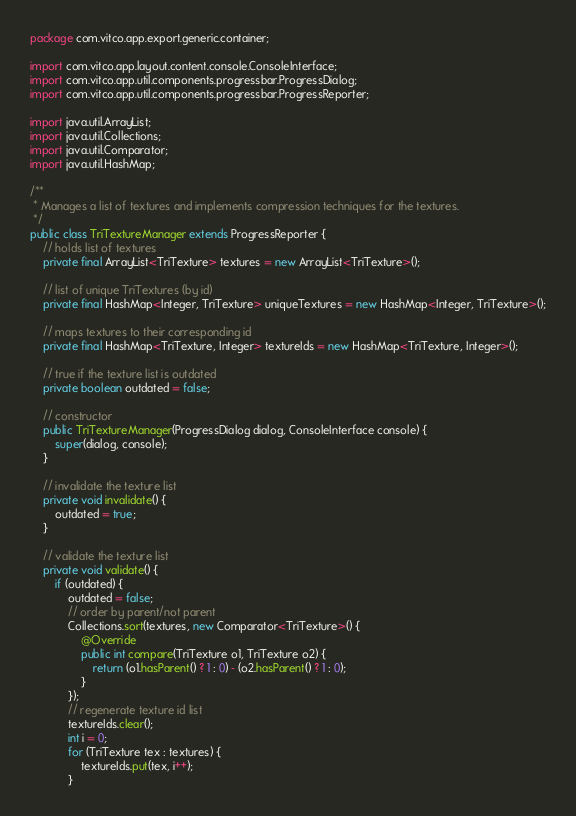Convert code to text. <code><loc_0><loc_0><loc_500><loc_500><_Java_>package com.vitco.app.export.generic.container;

import com.vitco.app.layout.content.console.ConsoleInterface;
import com.vitco.app.util.components.progressbar.ProgressDialog;
import com.vitco.app.util.components.progressbar.ProgressReporter;

import java.util.ArrayList;
import java.util.Collections;
import java.util.Comparator;
import java.util.HashMap;

/**
 * Manages a list of textures and implements compression techniques for the textures.
 */
public class TriTextureManager extends ProgressReporter {
    // holds list of textures
    private final ArrayList<TriTexture> textures = new ArrayList<TriTexture>();

    // list of unique TriTextures (by id)
    private final HashMap<Integer, TriTexture> uniqueTextures = new HashMap<Integer, TriTexture>();

    // maps textures to their corresponding id
    private final HashMap<TriTexture, Integer> textureIds = new HashMap<TriTexture, Integer>();

    // true if the texture list is outdated
    private boolean outdated = false;

    // constructor
    public TriTextureManager(ProgressDialog dialog, ConsoleInterface console) {
        super(dialog, console);
    }

    // invalidate the texture list
    private void invalidate() {
        outdated = true;
    }

    // validate the texture list
    private void validate() {
        if (outdated) {
            outdated = false;
            // order by parent/not parent
            Collections.sort(textures, new Comparator<TriTexture>() {
                @Override
                public int compare(TriTexture o1, TriTexture o2) {
                    return (o1.hasParent() ? 1 : 0) - (o2.hasParent() ? 1 : 0);
                }
            });
            // regenerate texture id list
            textureIds.clear();
            int i = 0;
            for (TriTexture tex : textures) {
                textureIds.put(tex, i++);
            }</code> 